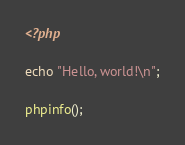Convert code to text. <code><loc_0><loc_0><loc_500><loc_500><_PHP_><?php

echo "Hello, world!\n";

phpinfo();
</code> 